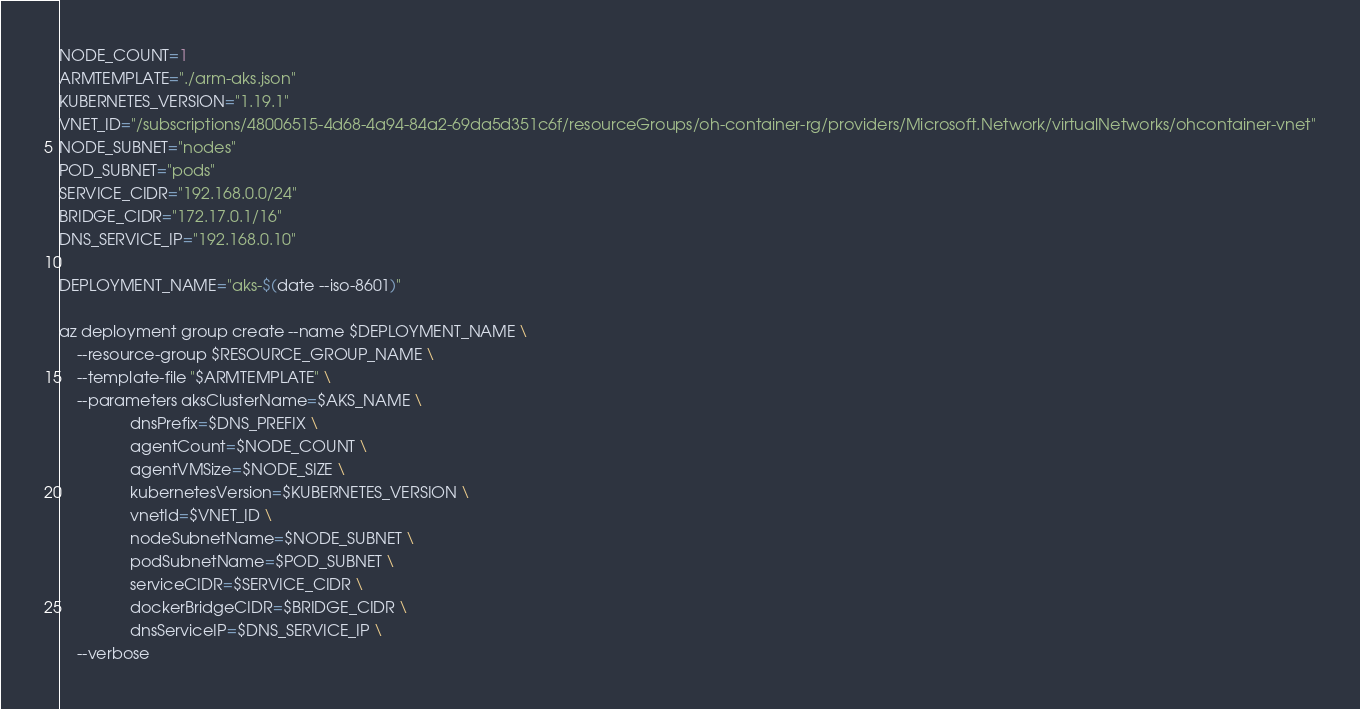Convert code to text. <code><loc_0><loc_0><loc_500><loc_500><_Bash_>NODE_COUNT=1
ARMTEMPLATE="./arm-aks.json"
KUBERNETES_VERSION="1.19.1"
VNET_ID="/subscriptions/48006515-4d68-4a94-84a2-69da5d351c6f/resourceGroups/oh-container-rg/providers/Microsoft.Network/virtualNetworks/ohcontainer-vnet"
NODE_SUBNET="nodes"
POD_SUBNET="pods"
SERVICE_CIDR="192.168.0.0/24"
BRIDGE_CIDR="172.17.0.1/16"
DNS_SERVICE_IP="192.168.0.10"

DEPLOYMENT_NAME="aks-$(date --iso-8601)"

az deployment group create --name $DEPLOYMENT_NAME \
    --resource-group $RESOURCE_GROUP_NAME \
    --template-file "$ARMTEMPLATE" \
    --parameters aksClusterName=$AKS_NAME \
                dnsPrefix=$DNS_PREFIX \
                agentCount=$NODE_COUNT \
                agentVMSize=$NODE_SIZE \
                kubernetesVersion=$KUBERNETES_VERSION \
                vnetId=$VNET_ID \
                nodeSubnetName=$NODE_SUBNET \
                podSubnetName=$POD_SUBNET \
                serviceCIDR=$SERVICE_CIDR \
                dockerBridgeCIDR=$BRIDGE_CIDR \
                dnsServiceIP=$DNS_SERVICE_IP \
    --verbose</code> 